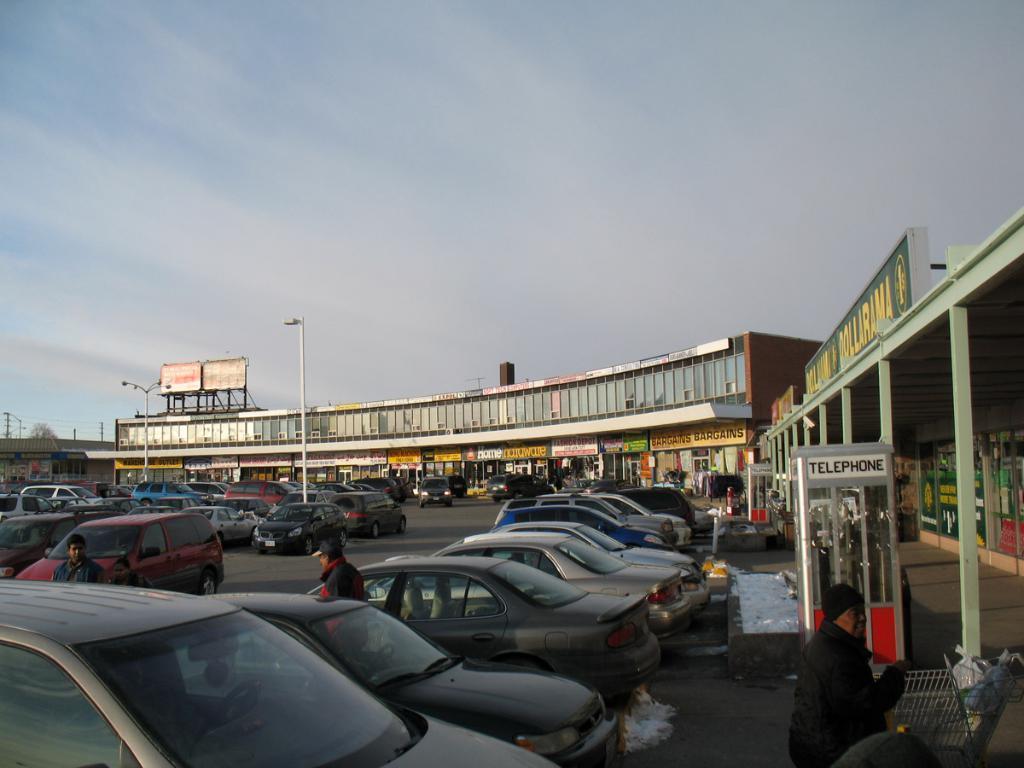Could you give a brief overview of what you see in this image? In this image, on the right side, we can see a person. In the right corner, we can also see some objects. On the right side, we can see some pillars, telephone box and a board, on the board, we can see some text written on it. In the middle of the image, we can see few cars which are placed on the road. In the middle of the image, we can also see a man. On the left side, we can also see a man, few vehicles. In the background, we can see some buildings, street lights, hoardings, board. On the board, we can see some text, trees, electric wires, electric pole, pillar. At the top, we can see a sky which is a bit cloudy, at the bottom, we can see a road and a footpath. 